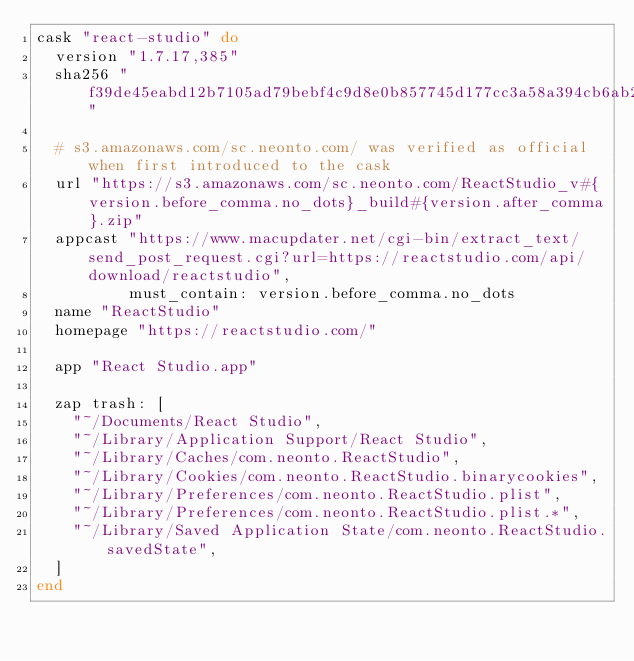Convert code to text. <code><loc_0><loc_0><loc_500><loc_500><_Ruby_>cask "react-studio" do
  version "1.7.17,385"
  sha256 "f39de45eabd12b7105ad79bebf4c9d8e0b857745d177cc3a58a394cb6ab25a8d"

  # s3.amazonaws.com/sc.neonto.com/ was verified as official when first introduced to the cask
  url "https://s3.amazonaws.com/sc.neonto.com/ReactStudio_v#{version.before_comma.no_dots}_build#{version.after_comma}.zip"
  appcast "https://www.macupdater.net/cgi-bin/extract_text/send_post_request.cgi?url=https://reactstudio.com/api/download/reactstudio",
          must_contain: version.before_comma.no_dots
  name "ReactStudio"
  homepage "https://reactstudio.com/"

  app "React Studio.app"

  zap trash: [
    "~/Documents/React Studio",
    "~/Library/Application Support/React Studio",
    "~/Library/Caches/com.neonto.ReactStudio",
    "~/Library/Cookies/com.neonto.ReactStudio.binarycookies",
    "~/Library/Preferences/com.neonto.ReactStudio.plist",
    "~/Library/Preferences/com.neonto.ReactStudio.plist.*",
    "~/Library/Saved Application State/com.neonto.ReactStudio.savedState",
  ]
end
</code> 